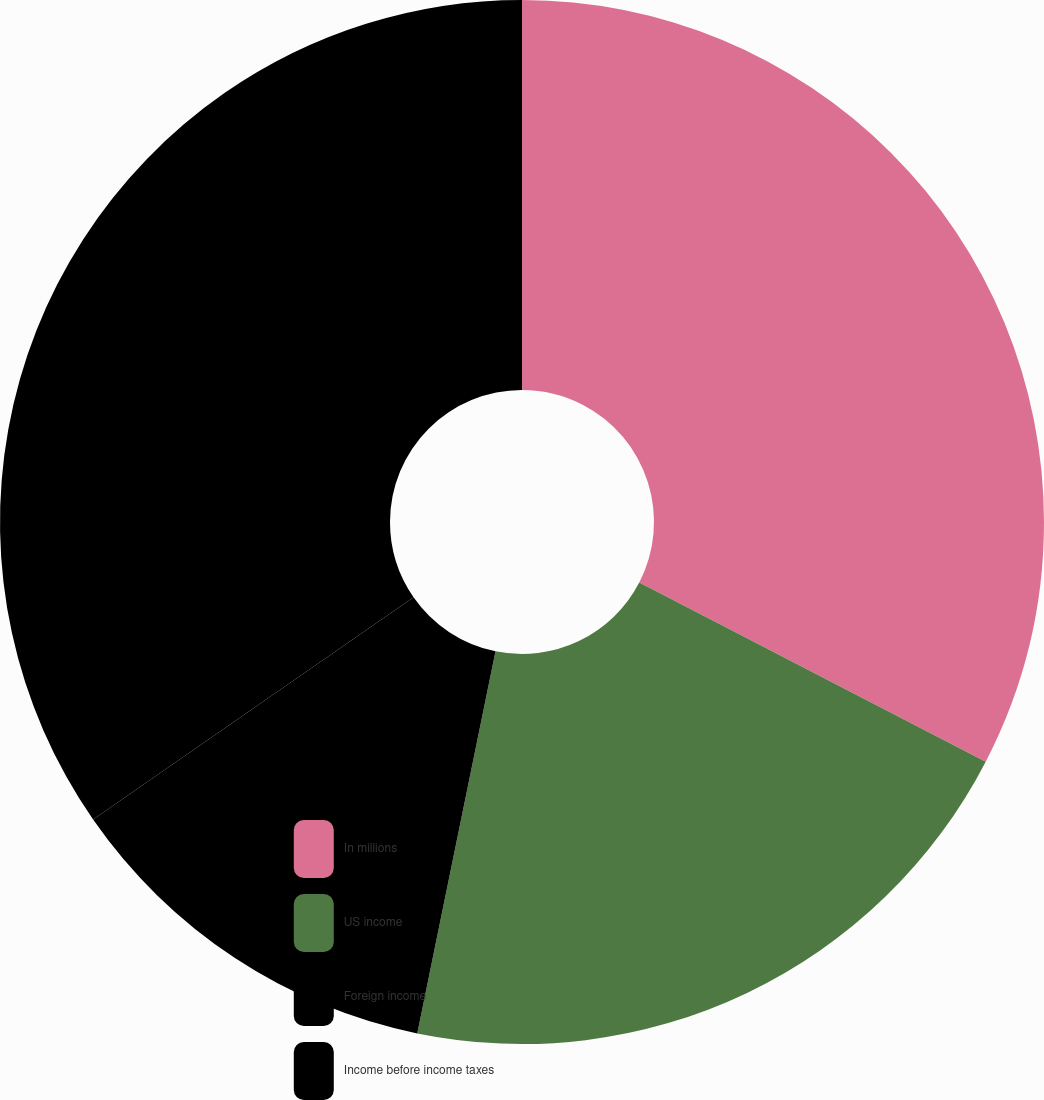Convert chart. <chart><loc_0><loc_0><loc_500><loc_500><pie_chart><fcel>In millions<fcel>US income<fcel>Foreign income<fcel>Income before income taxes<nl><fcel>32.59%<fcel>20.62%<fcel>12.13%<fcel>34.65%<nl></chart> 